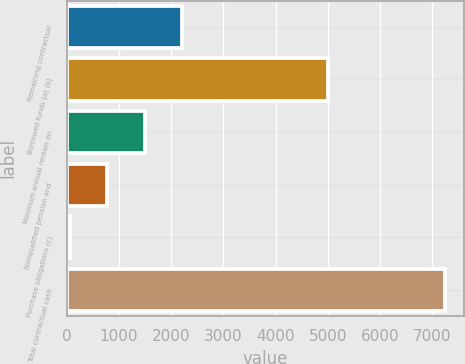<chart> <loc_0><loc_0><loc_500><loc_500><bar_chart><fcel>Remaining contractual<fcel>Borrowed funds (a) (b)<fcel>Minimum annual rentals on<fcel>Nonqualified pension and<fcel>Purchase obligations (c)<fcel>Total contractual cash<nl><fcel>2214.8<fcel>5005<fcel>1495.2<fcel>775.6<fcel>56<fcel>7252<nl></chart> 